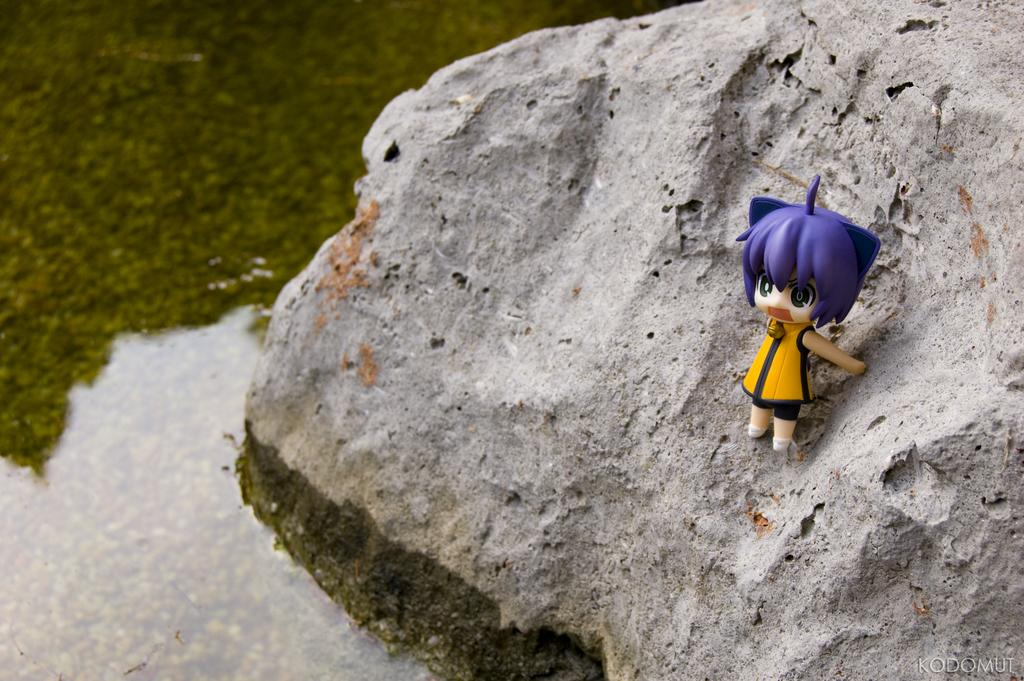What is located on the left side of the image? There is water on the left side of the image. What can be seen on the right side of the image? There is a toy girl on a rock on the right side of the image. Where is the watermark in the image? The watermark is on the bottom right of the image. Can you describe the background of the image? The background of the image is blurred}. Can you see a whip being used by the toy girl in the image? There is no whip present in the image, and the toy girl is not using any object. Are there any monkeys visible in the image? There are no monkeys present in the image. 